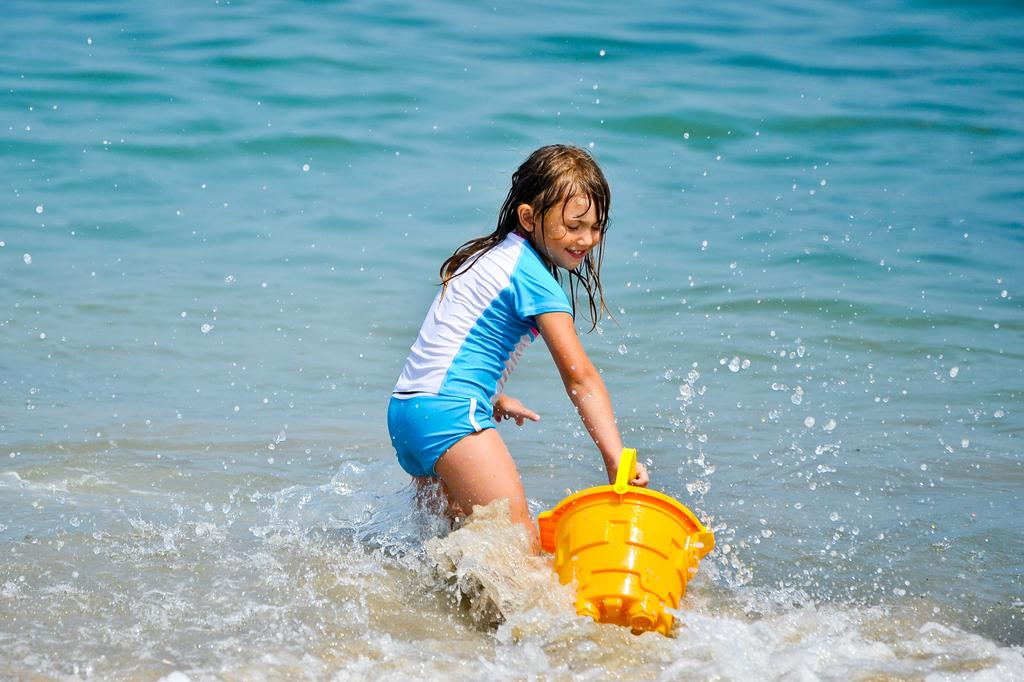Who is the main subject in the image? There is a girl in the image. What is the girl holding in her hand? The girl is holding a bucket in her hand. Can you describe the girl's position in relation to the water? The girl is partially in the water. What type of scene is depicted in the image? The image does not depict a specific scene; it simply shows a girl holding a bucket and being partially in the water. What arithmetic problem is the girl trying to solve in the image? There is no arithmetic problem present in the image. What type of writing instrument is the girl using in the image? There is no writing instrument, such as a quill, present in the image. 